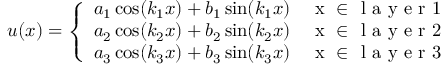<formula> <loc_0><loc_0><loc_500><loc_500>u ( x ) = \left \{ \begin{array} { l l } { a _ { 1 } \cos ( k _ { 1 } x ) + b _ { 1 } \sin ( k _ { 1 } x ) } & { x \in l a y e r 1 } \\ { a _ { 2 } \cos ( k _ { 2 } x ) + b _ { 2 } \sin ( k _ { 2 } x ) } & { x \in l a y e r 2 } \\ { a _ { 3 } \cos ( k _ { 3 } x ) + b _ { 3 } \sin ( k _ { 3 } x ) } & { x \in l a y e r 3 } \end{array}</formula> 